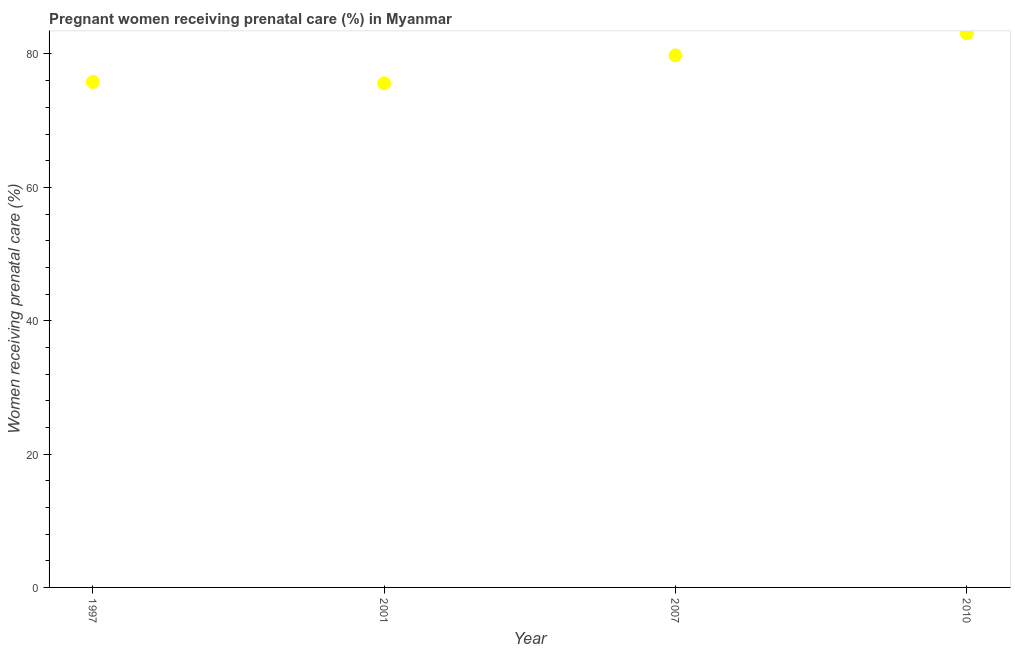What is the percentage of pregnant women receiving prenatal care in 2001?
Your answer should be compact. 75.6. Across all years, what is the maximum percentage of pregnant women receiving prenatal care?
Ensure brevity in your answer.  83.1. Across all years, what is the minimum percentage of pregnant women receiving prenatal care?
Keep it short and to the point. 75.6. In which year was the percentage of pregnant women receiving prenatal care maximum?
Offer a terse response. 2010. What is the sum of the percentage of pregnant women receiving prenatal care?
Provide a short and direct response. 314.3. What is the difference between the percentage of pregnant women receiving prenatal care in 1997 and 2007?
Keep it short and to the point. -4. What is the average percentage of pregnant women receiving prenatal care per year?
Keep it short and to the point. 78.57. What is the median percentage of pregnant women receiving prenatal care?
Your response must be concise. 77.8. What is the ratio of the percentage of pregnant women receiving prenatal care in 1997 to that in 2001?
Offer a terse response. 1. Is the percentage of pregnant women receiving prenatal care in 1997 less than that in 2010?
Provide a succinct answer. Yes. What is the difference between the highest and the second highest percentage of pregnant women receiving prenatal care?
Provide a succinct answer. 3.3. Is the sum of the percentage of pregnant women receiving prenatal care in 2001 and 2010 greater than the maximum percentage of pregnant women receiving prenatal care across all years?
Your answer should be very brief. Yes. Does the percentage of pregnant women receiving prenatal care monotonically increase over the years?
Offer a terse response. No. How many years are there in the graph?
Keep it short and to the point. 4. Are the values on the major ticks of Y-axis written in scientific E-notation?
Keep it short and to the point. No. What is the title of the graph?
Make the answer very short. Pregnant women receiving prenatal care (%) in Myanmar. What is the label or title of the X-axis?
Ensure brevity in your answer.  Year. What is the label or title of the Y-axis?
Your answer should be compact. Women receiving prenatal care (%). What is the Women receiving prenatal care (%) in 1997?
Give a very brief answer. 75.8. What is the Women receiving prenatal care (%) in 2001?
Provide a short and direct response. 75.6. What is the Women receiving prenatal care (%) in 2007?
Give a very brief answer. 79.8. What is the Women receiving prenatal care (%) in 2010?
Your response must be concise. 83.1. What is the difference between the Women receiving prenatal care (%) in 2007 and 2010?
Keep it short and to the point. -3.3. What is the ratio of the Women receiving prenatal care (%) in 1997 to that in 2007?
Provide a succinct answer. 0.95. What is the ratio of the Women receiving prenatal care (%) in 1997 to that in 2010?
Your answer should be very brief. 0.91. What is the ratio of the Women receiving prenatal care (%) in 2001 to that in 2007?
Provide a succinct answer. 0.95. What is the ratio of the Women receiving prenatal care (%) in 2001 to that in 2010?
Ensure brevity in your answer.  0.91. 